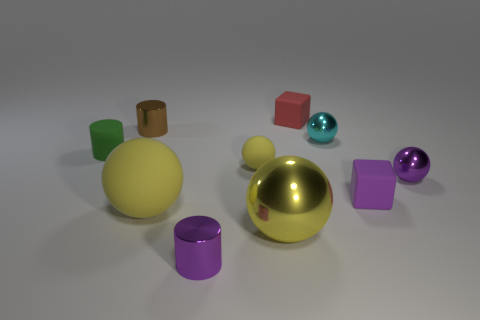The yellow thing that is behind the yellow matte object on the left side of the tiny shiny cylinder that is in front of the green object is made of what material?
Offer a terse response. Rubber. What number of other things are the same size as the red object?
Offer a very short reply. 7. The shiny sphere that is the same color as the big rubber object is what size?
Ensure brevity in your answer.  Large. Are there more brown things that are in front of the purple block than blue things?
Offer a terse response. No. Are there any tiny metallic blocks that have the same color as the big shiny thing?
Give a very brief answer. No. The other rubber ball that is the same size as the cyan sphere is what color?
Keep it short and to the point. Yellow. How many yellow rubber objects are in front of the big thing that is behind the big shiny ball?
Offer a very short reply. 0. How many things are matte things that are left of the purple rubber block or yellow shiny objects?
Your response must be concise. 5. How many tiny green objects have the same material as the tiny purple cylinder?
Offer a very short reply. 0. What shape is the big matte thing that is the same color as the large metal sphere?
Your response must be concise. Sphere. 